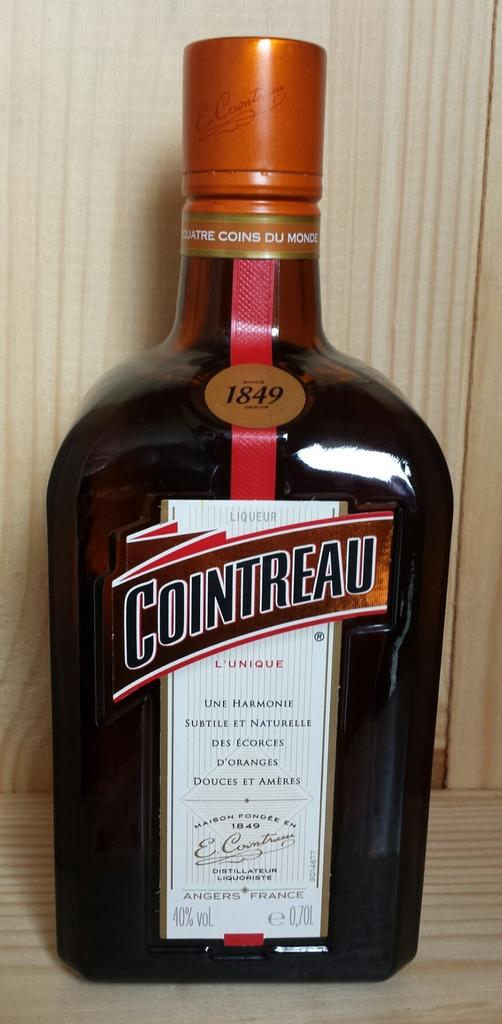What brand is this liquor?
Keep it short and to the point. Cointreau. 